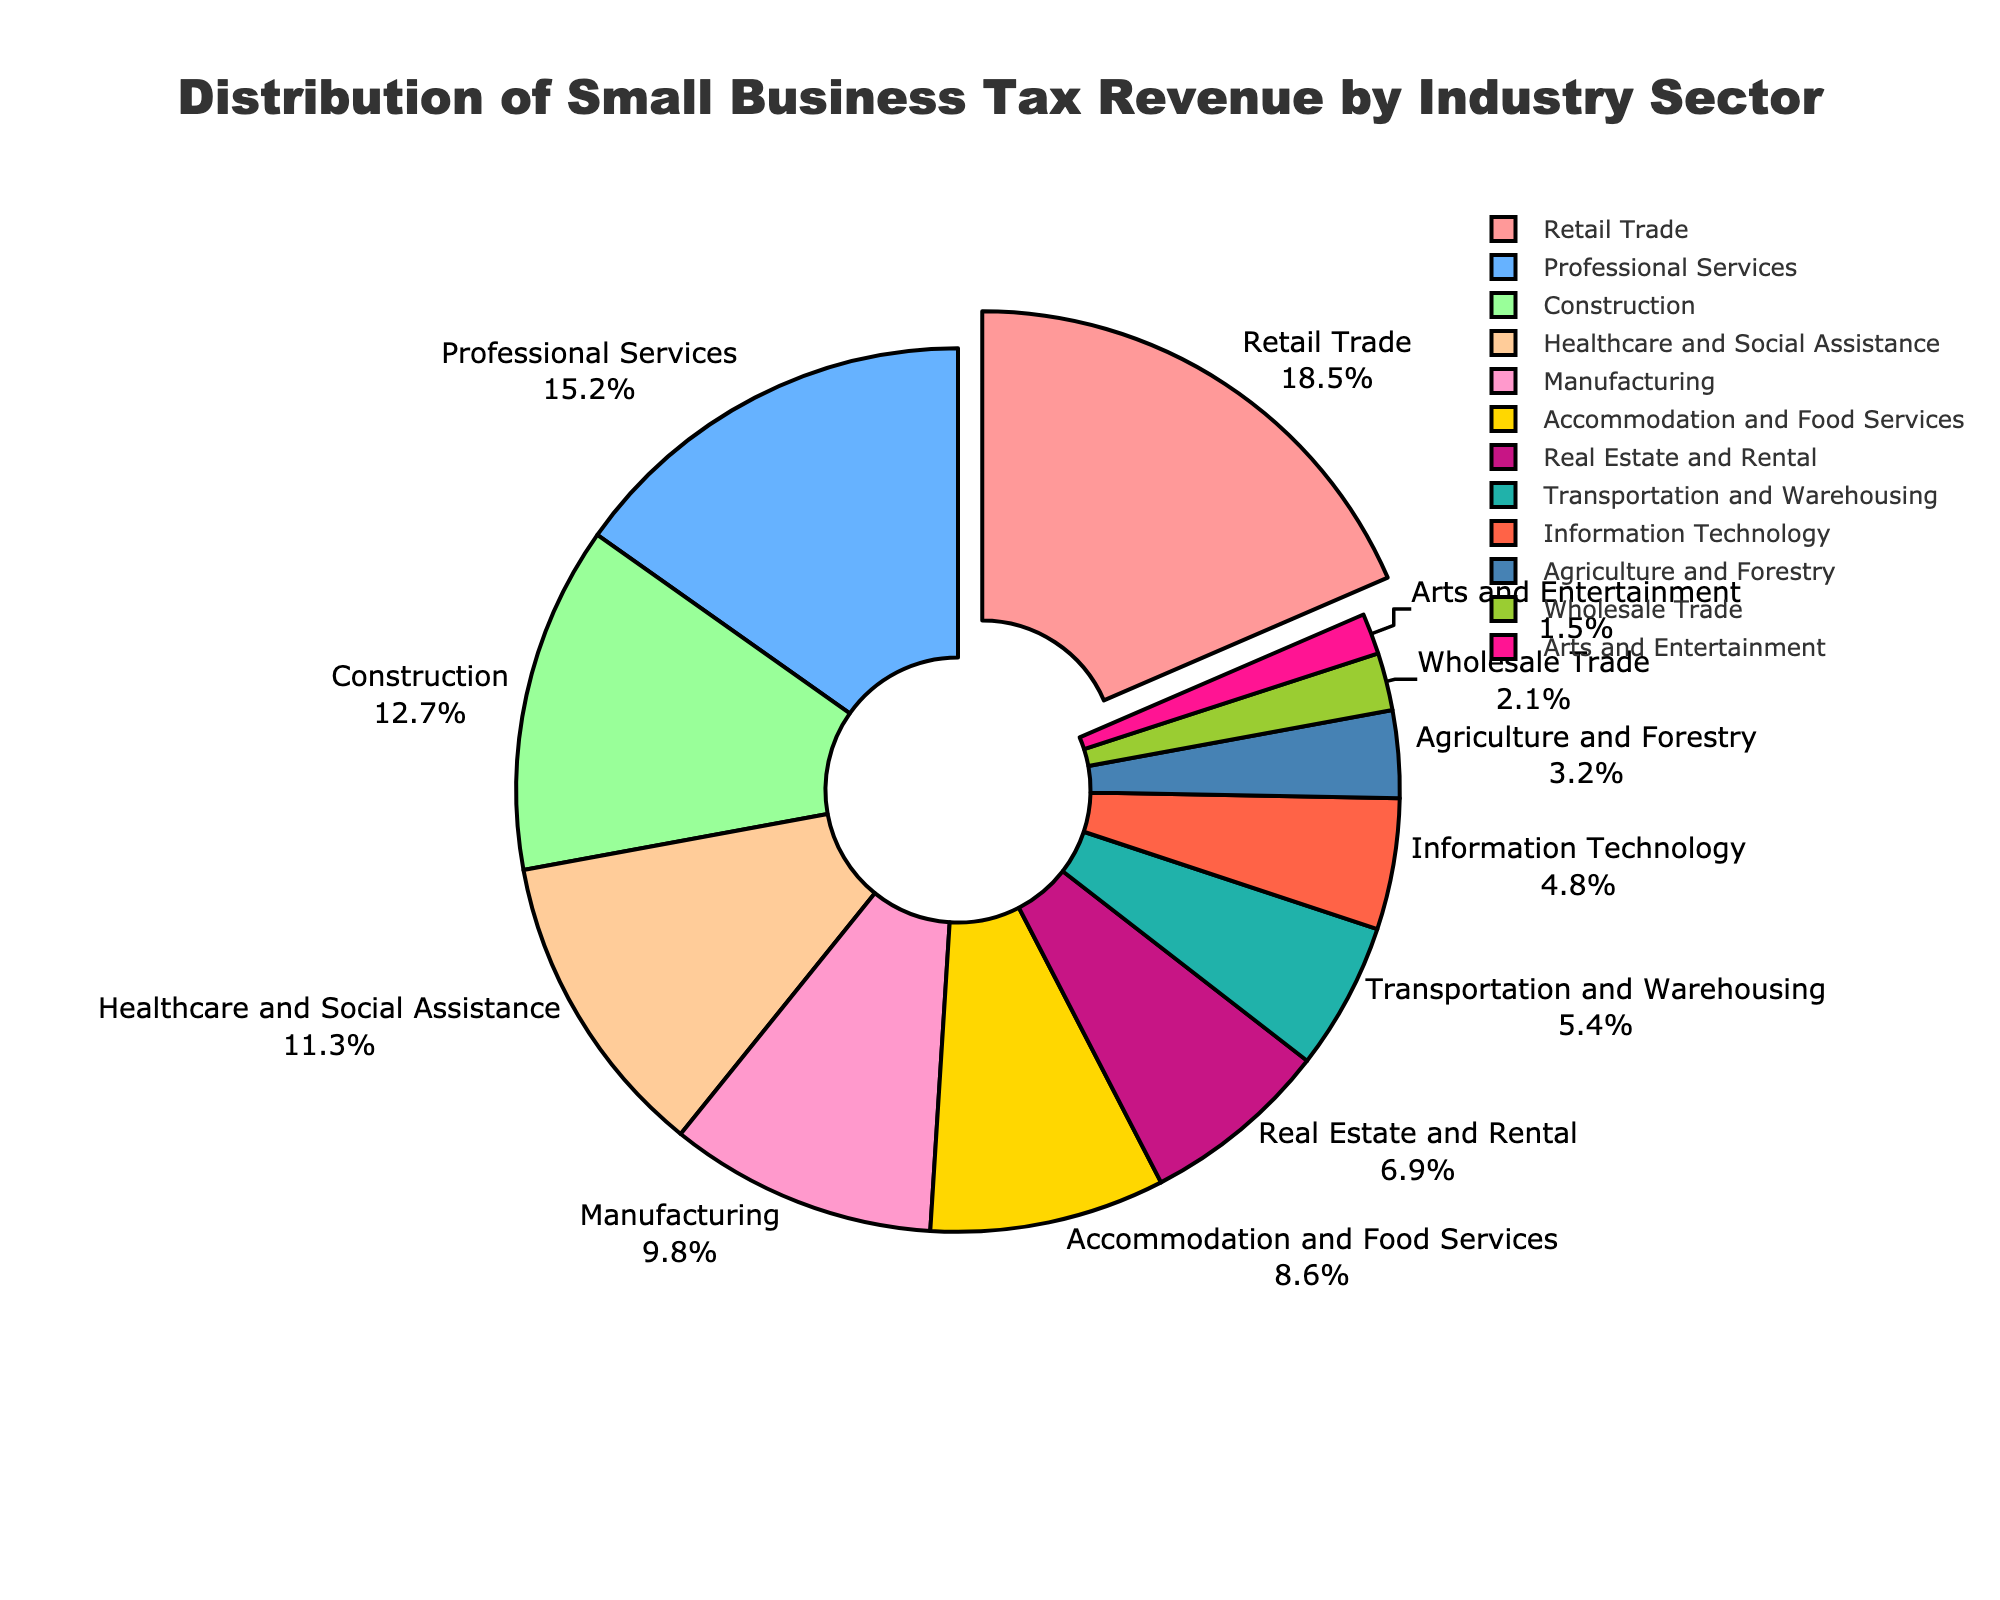what percentage of small business tax revenue is generated by the Retail Trade sector? Locate the Retail Trade sector on the pie chart and note the attached percentage.
Answer: 18.5% Which industry contributes more to the tax revenue, Construction or Healthcare and Social Assistance? Find the Construction sector (12.7%) and Healthcare and Social Assistance sector (11.3%) on the pie chart, then compare their percentages.
Answer: Construction What is the combined tax revenue percentage of the Manufacturing and Information Technology sectors? Locate the Manufacturing sector (9.8%) and Information Technology sector (4.8%), then sum their percentages: 9.8 + 4.8 = 14.6.
Answer: 14.6% Compare the tax revenue contribution between the Real Estate and Rental sector and the Transportation and Warehousing sector. Which one is higher and by how much? Identify the Real Estate and Rental sector (6.9%) and Transportation and Warehousing sector (5.4%). Calculate the difference: 6.9 - 5.4 = 1.5.
Answer: Real Estate and Rental by 1.5% Which sector has the smallest tax revenue percentage and what is its value? Find the smallest slice on the pie chart, which is the Arts and Entertainment sector, and note the percentage.
Answer: Arts and Entertainment, 1.5% How does the tax revenue percentage of the Professional Services sector compare to the Accommodation and Food Services sector? Compare the percentages: Professional Services (15.2%) vs. Accommodation and Food Services (8.6%). 15.2% is greater than 8.6%.
Answer: Professional Services is higher What is the total percentage of tax revenue generated by sectors contributing less than 5% each? Identify the sectors with percentages less than 5%: Transportation and Warehousing (5.4% does not qualify), Information Technology (4.8%), Agriculture and Forestry (3.2%), Wholesale Trade (2.1%), Arts and Entertainment (1.5%). Sum these values: 4.8 + 3.2 + 2.1 + 1.5 = 11.6.
Answer: 11.6% By how much percent does the Retail Trade sector exceed the Real Estate and Rental sector in tax revenue contribution? Find Retail Trade (18.5%) and Real Estate and Rental (6.9%), then calculate the difference: 18.5 - 6.9 = 11.6.
Answer: 11.6% 